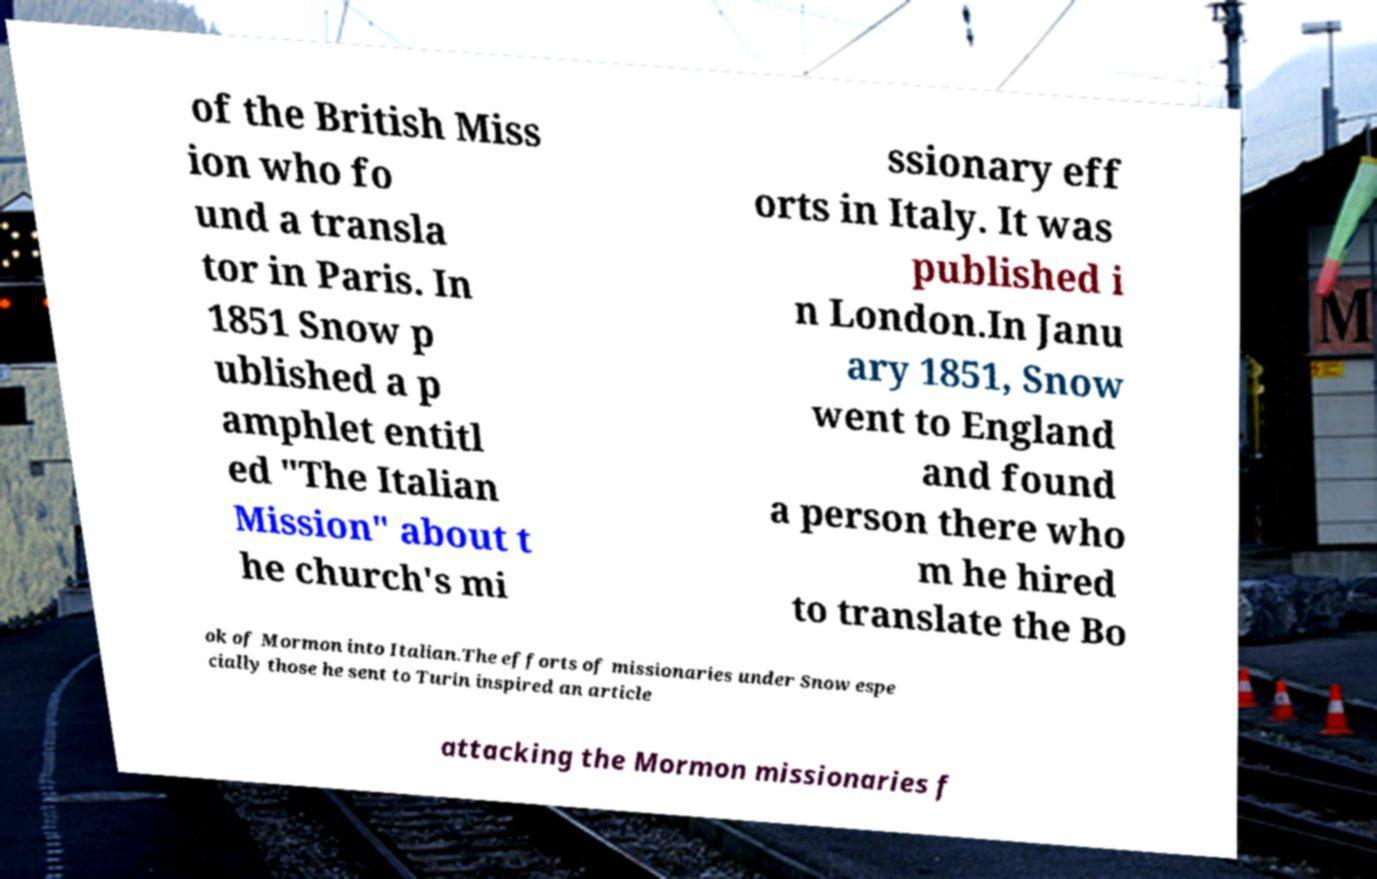I need the written content from this picture converted into text. Can you do that? of the British Miss ion who fo und a transla tor in Paris. In 1851 Snow p ublished a p amphlet entitl ed "The Italian Mission" about t he church's mi ssionary eff orts in Italy. It was published i n London.In Janu ary 1851, Snow went to England and found a person there who m he hired to translate the Bo ok of Mormon into Italian.The efforts of missionaries under Snow espe cially those he sent to Turin inspired an article attacking the Mormon missionaries f 